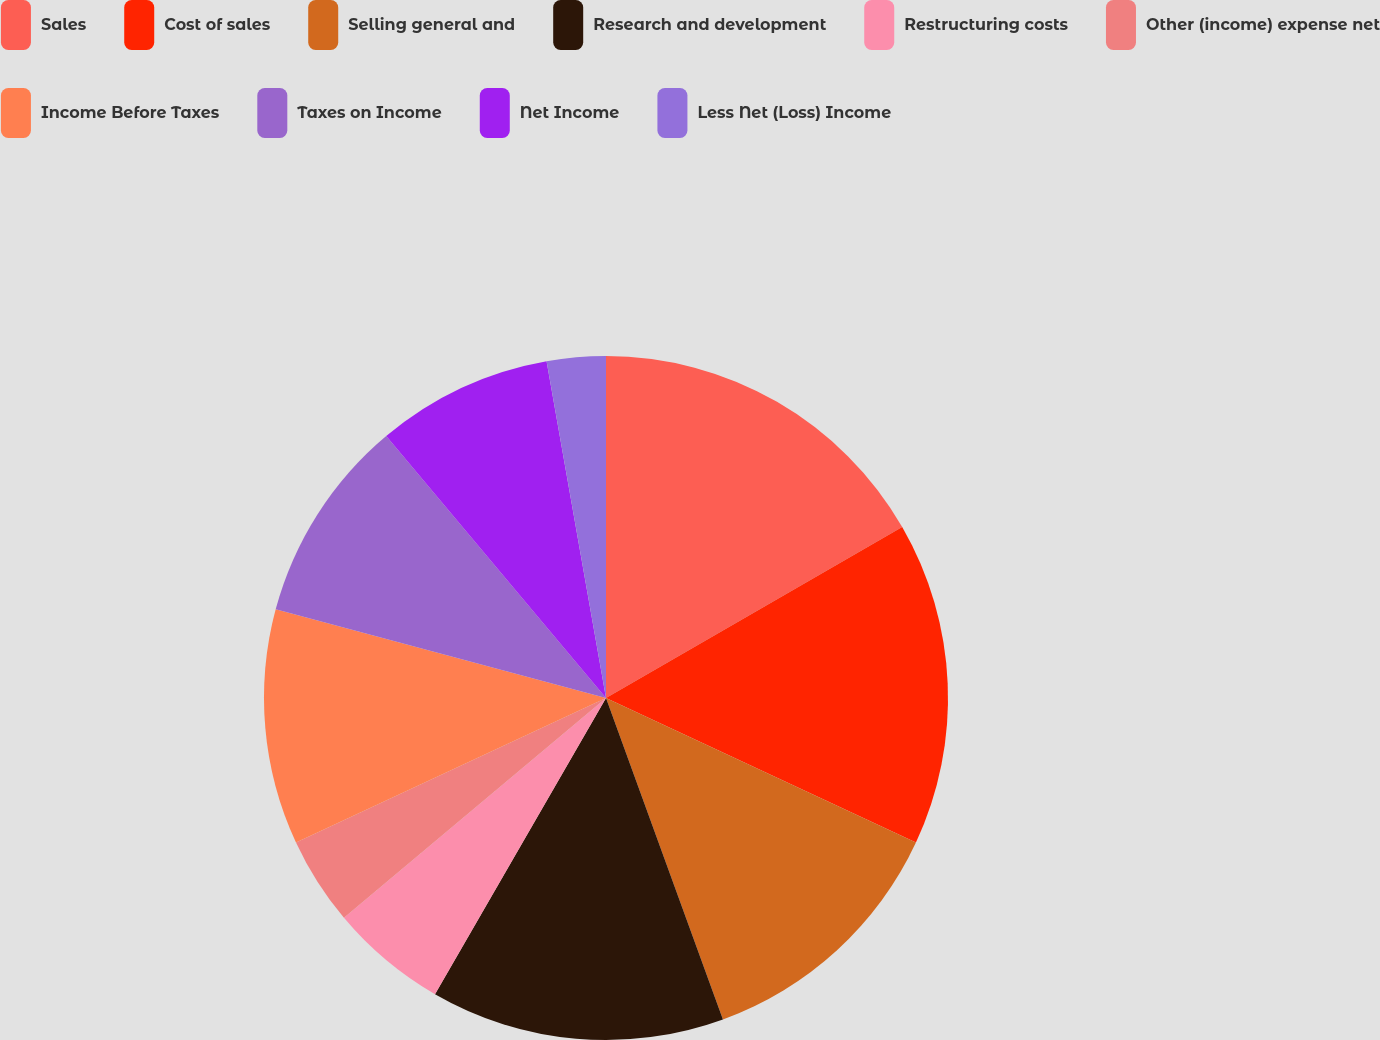Convert chart. <chart><loc_0><loc_0><loc_500><loc_500><pie_chart><fcel>Sales<fcel>Cost of sales<fcel>Selling general and<fcel>Research and development<fcel>Restructuring costs<fcel>Other (income) expense net<fcel>Income Before Taxes<fcel>Taxes on Income<fcel>Net Income<fcel>Less Net (Loss) Income<nl><fcel>16.67%<fcel>15.28%<fcel>12.5%<fcel>13.89%<fcel>5.56%<fcel>4.17%<fcel>11.11%<fcel>9.72%<fcel>8.33%<fcel>2.78%<nl></chart> 